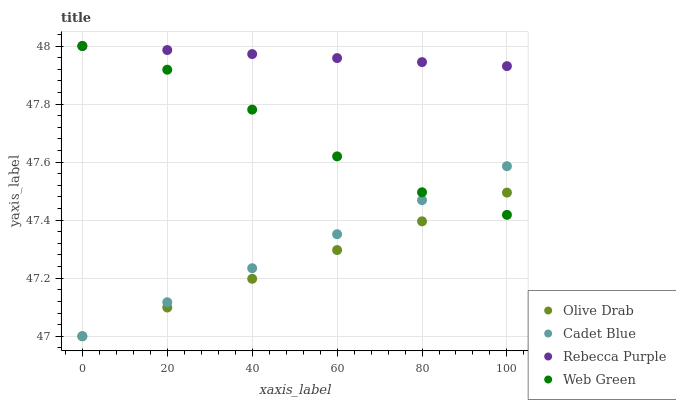Does Olive Drab have the minimum area under the curve?
Answer yes or no. Yes. Does Rebecca Purple have the maximum area under the curve?
Answer yes or no. Yes. Does Cadet Blue have the minimum area under the curve?
Answer yes or no. No. Does Cadet Blue have the maximum area under the curve?
Answer yes or no. No. Is Olive Drab the smoothest?
Answer yes or no. Yes. Is Web Green the roughest?
Answer yes or no. Yes. Is Cadet Blue the smoothest?
Answer yes or no. No. Is Cadet Blue the roughest?
Answer yes or no. No. Does Cadet Blue have the lowest value?
Answer yes or no. Yes. Does Rebecca Purple have the lowest value?
Answer yes or no. No. Does Rebecca Purple have the highest value?
Answer yes or no. Yes. Does Cadet Blue have the highest value?
Answer yes or no. No. Is Cadet Blue less than Rebecca Purple?
Answer yes or no. Yes. Is Rebecca Purple greater than Cadet Blue?
Answer yes or no. Yes. Does Olive Drab intersect Web Green?
Answer yes or no. Yes. Is Olive Drab less than Web Green?
Answer yes or no. No. Is Olive Drab greater than Web Green?
Answer yes or no. No. Does Cadet Blue intersect Rebecca Purple?
Answer yes or no. No. 